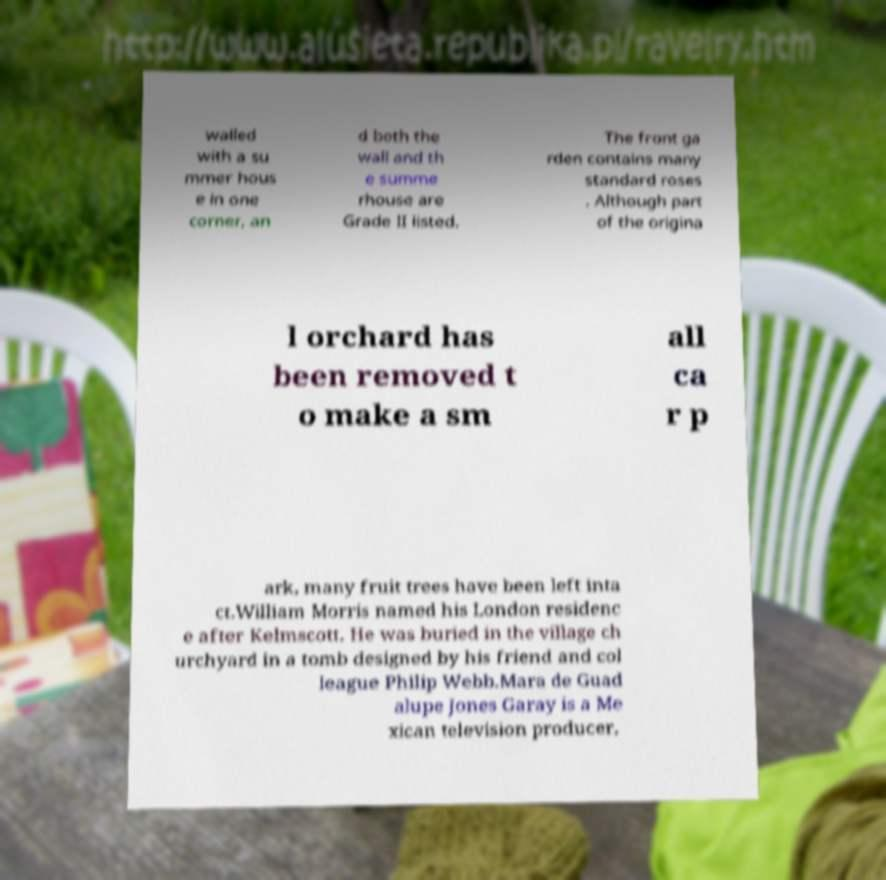Could you extract and type out the text from this image? walled with a su mmer hous e in one corner, an d both the wall and th e summe rhouse are Grade II listed. The front ga rden contains many standard roses . Although part of the origina l orchard has been removed t o make a sm all ca r p ark, many fruit trees have been left inta ct.William Morris named his London residenc e after Kelmscott. He was buried in the village ch urchyard in a tomb designed by his friend and col league Philip Webb.Mara de Guad alupe Jones Garay is a Me xican television producer, 